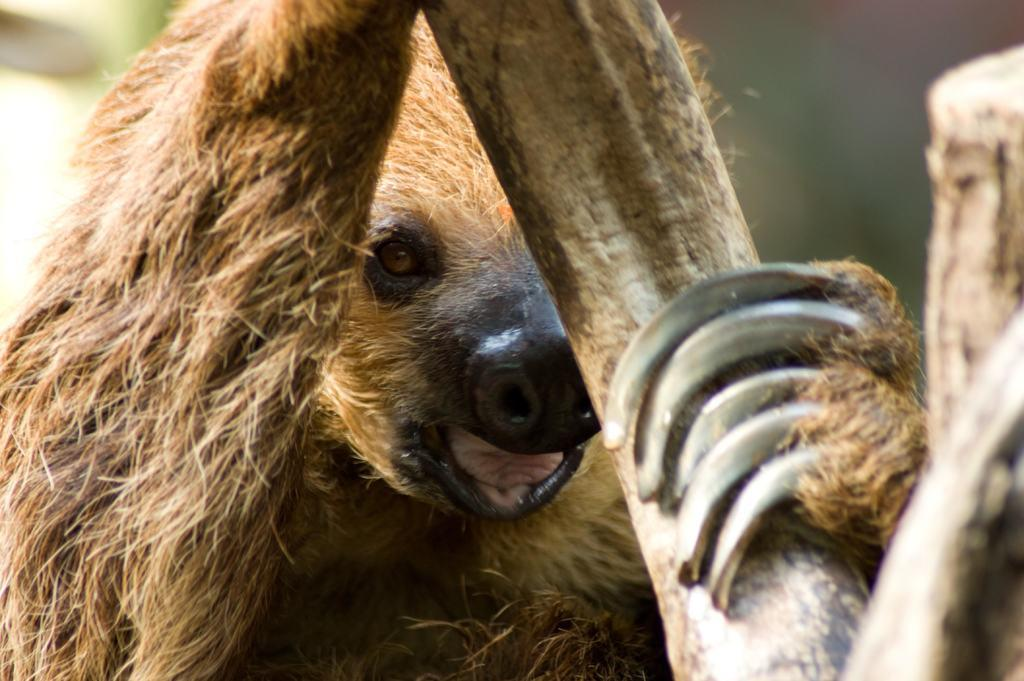What type of animal is in the foreground of the image? There is an animal in the foreground of the image, but the specific type of animal is not mentioned in the facts. What is the animal holding in the image? The animal is holding a stick. Can you describe the background of the image? The background of the image is blurred. What type of hope can be seen growing in the background of the image? There is no mention of hope in the image; it is not a visible object or concept. Can you tell me where the playground is located in the image? There is no playground present in the image. What type of railway can be seen in the image? There is no railway present in the image. 